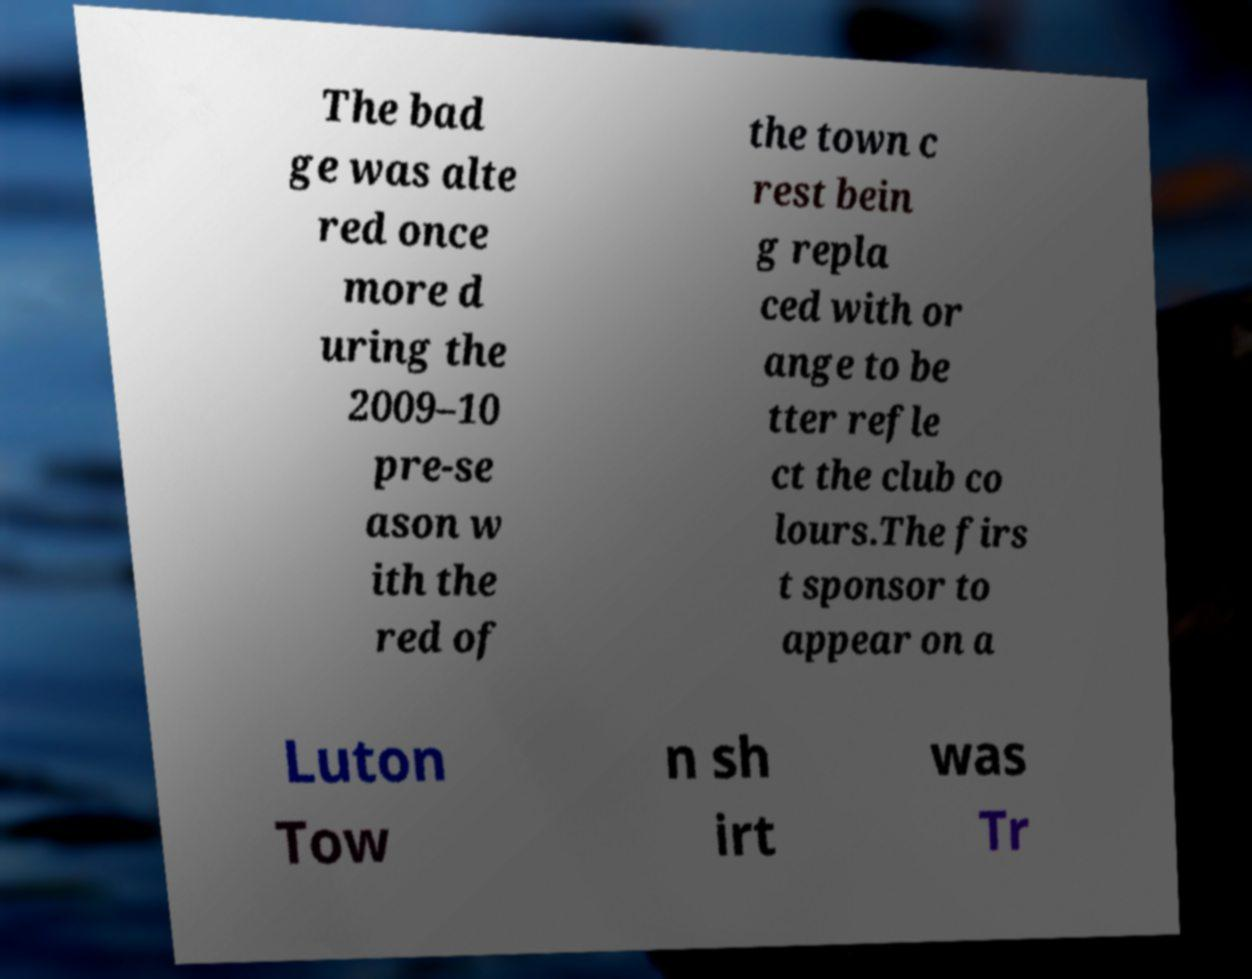Can you accurately transcribe the text from the provided image for me? The bad ge was alte red once more d uring the 2009–10 pre-se ason w ith the red of the town c rest bein g repla ced with or ange to be tter refle ct the club co lours.The firs t sponsor to appear on a Luton Tow n sh irt was Tr 